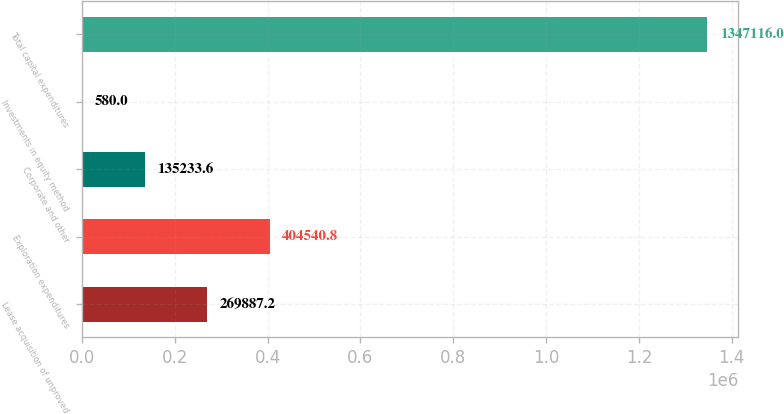Convert chart to OTSL. <chart><loc_0><loc_0><loc_500><loc_500><bar_chart><fcel>Lease acquisition of unproved<fcel>Exploration expenditures<fcel>Corporate and other<fcel>Investments in equity method<fcel>Total capital expenditures<nl><fcel>269887<fcel>404541<fcel>135234<fcel>580<fcel>1.34712e+06<nl></chart> 